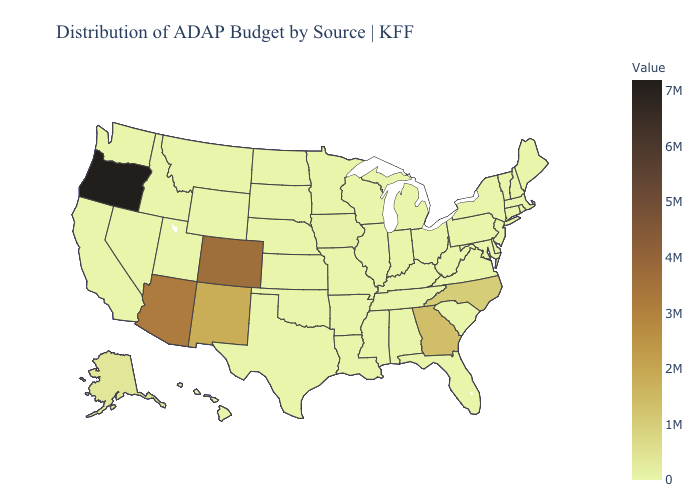Which states have the lowest value in the USA?
Write a very short answer. Alabama, Arkansas, California, Connecticut, Delaware, Florida, Hawaii, Idaho, Illinois, Indiana, Kansas, Kentucky, Louisiana, Maine, Maryland, Massachusetts, Michigan, Minnesota, Mississippi, Missouri, Montana, Nebraska, Nevada, New Hampshire, New Jersey, New York, North Dakota, Ohio, Oklahoma, Pennsylvania, Rhode Island, South Carolina, South Dakota, Tennessee, Texas, Utah, Vermont, Virginia, Washington, West Virginia, Wisconsin, Wyoming. Among the states that border Utah , does Wyoming have the highest value?
Keep it brief. No. Does Oregon have the lowest value in the West?
Write a very short answer. No. Does Iowa have the highest value in the MidWest?
Be succinct. Yes. Which states hav the highest value in the Northeast?
Give a very brief answer. Connecticut, Maine, Massachusetts, New Hampshire, New Jersey, New York, Pennsylvania, Rhode Island, Vermont. Does Virginia have the highest value in the South?
Quick response, please. No. Among the states that border Oregon , which have the lowest value?
Keep it brief. California, Idaho, Nevada, Washington. 